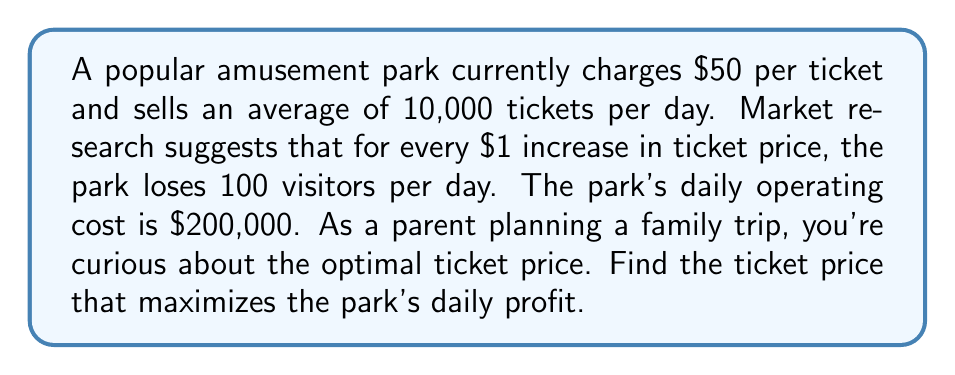Solve this math problem. Let's approach this step-by-step:

1) Define variables:
   $x$ = price increase in dollars
   $P$ = profit function

2) Express number of visitors in terms of $x$:
   Visitors = $10000 - 100x$

3) Express revenue function:
   Revenue = (Price per ticket) × (Number of visitors)
   $R(x) = (50 + x)(10000 - 100x)$

4) Expand the revenue function:
   $R(x) = 500000 + 10000x - 5000x - 100x^2$
   $R(x) = 500000 + 5000x - 100x^2$

5) Express profit function:
   Profit = Revenue - Cost
   $P(x) = R(x) - 200000$
   $P(x) = 300000 + 5000x - 100x^2$

6) To maximize profit, find where $\frac{dP}{dx} = 0$:
   $\frac{dP}{dx} = 5000 - 200x$

7) Set derivative to zero and solve:
   $5000 - 200x = 0$
   $200x = 5000$
   $x = 25$

8) Verify it's a maximum using the second derivative:
   $\frac{d^2P}{dx^2} = -200 < 0$, confirming a maximum

9) Calculate the optimal price:
   Original price + Increase = $50 + $25 = $75

Therefore, the optimal ticket price is $75.
Answer: $75 